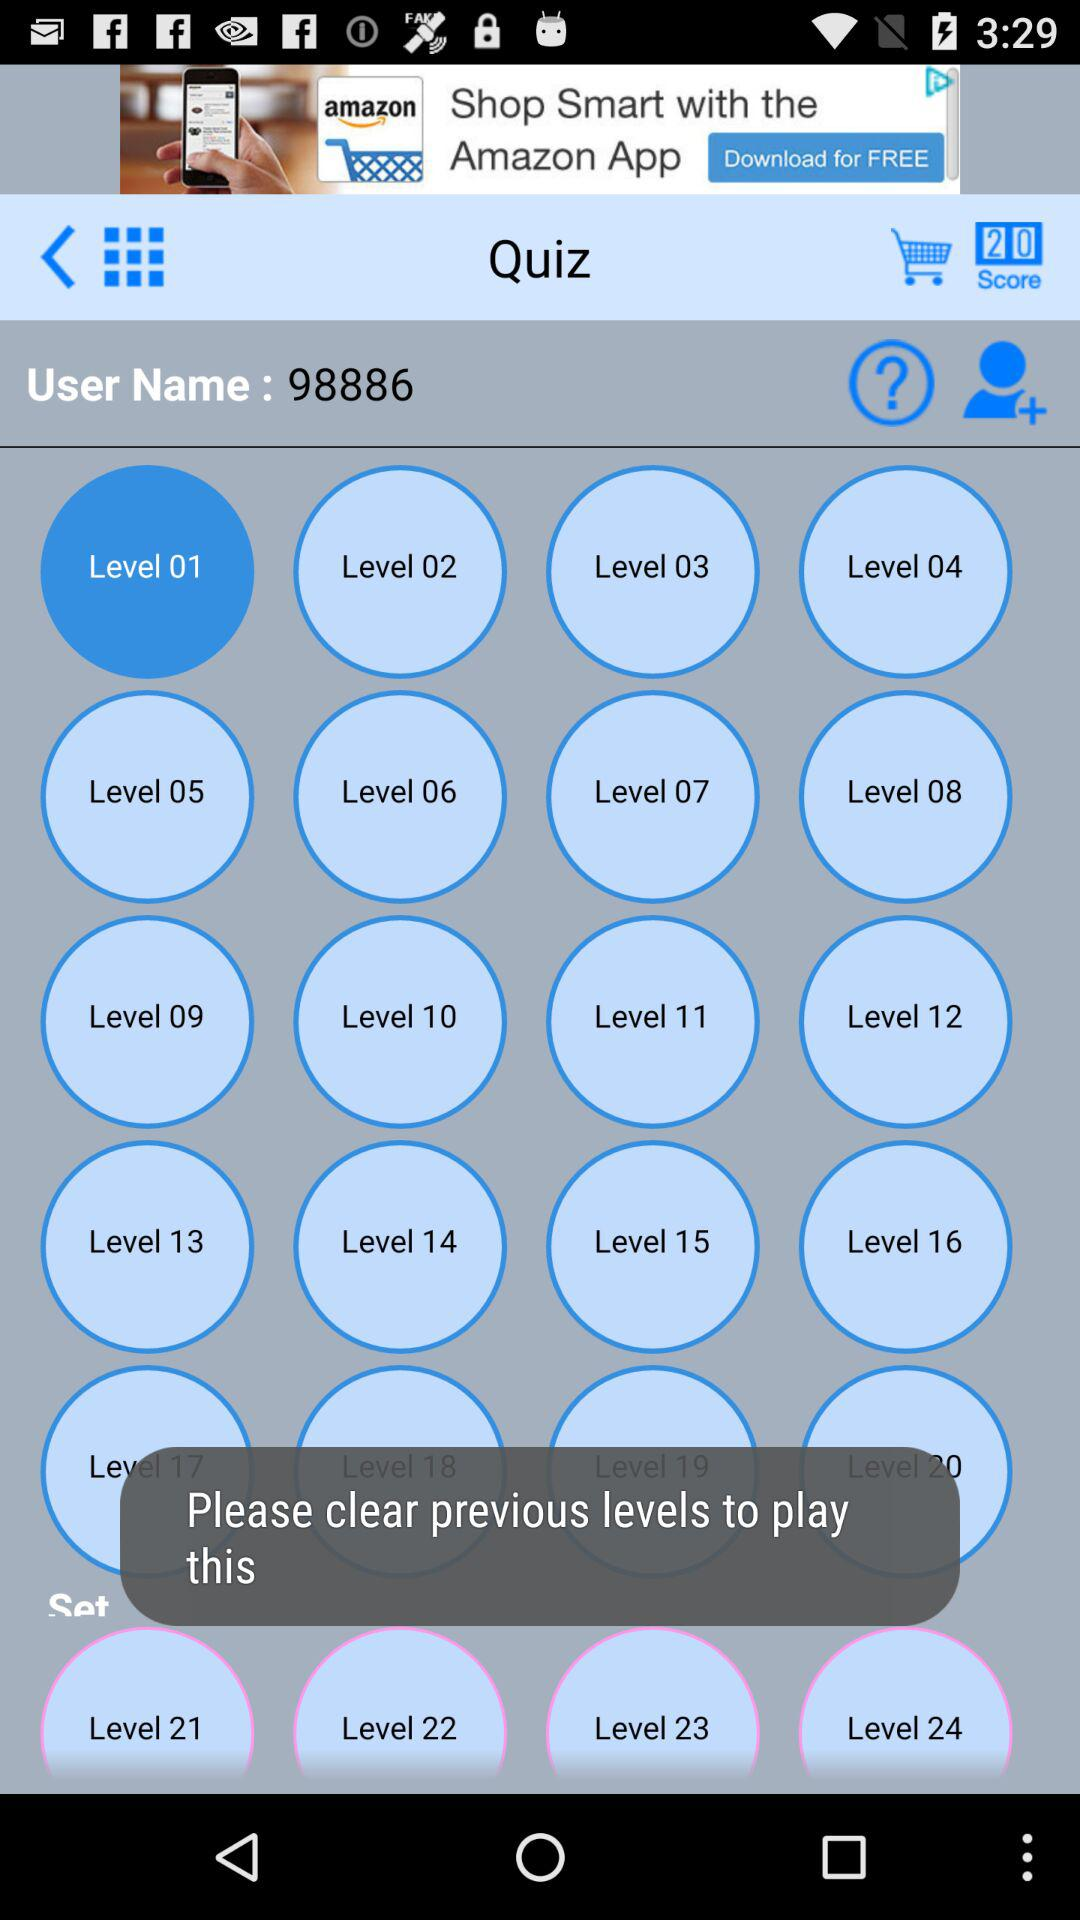How many levels are there in total?
Answer the question using a single word or phrase. 24 